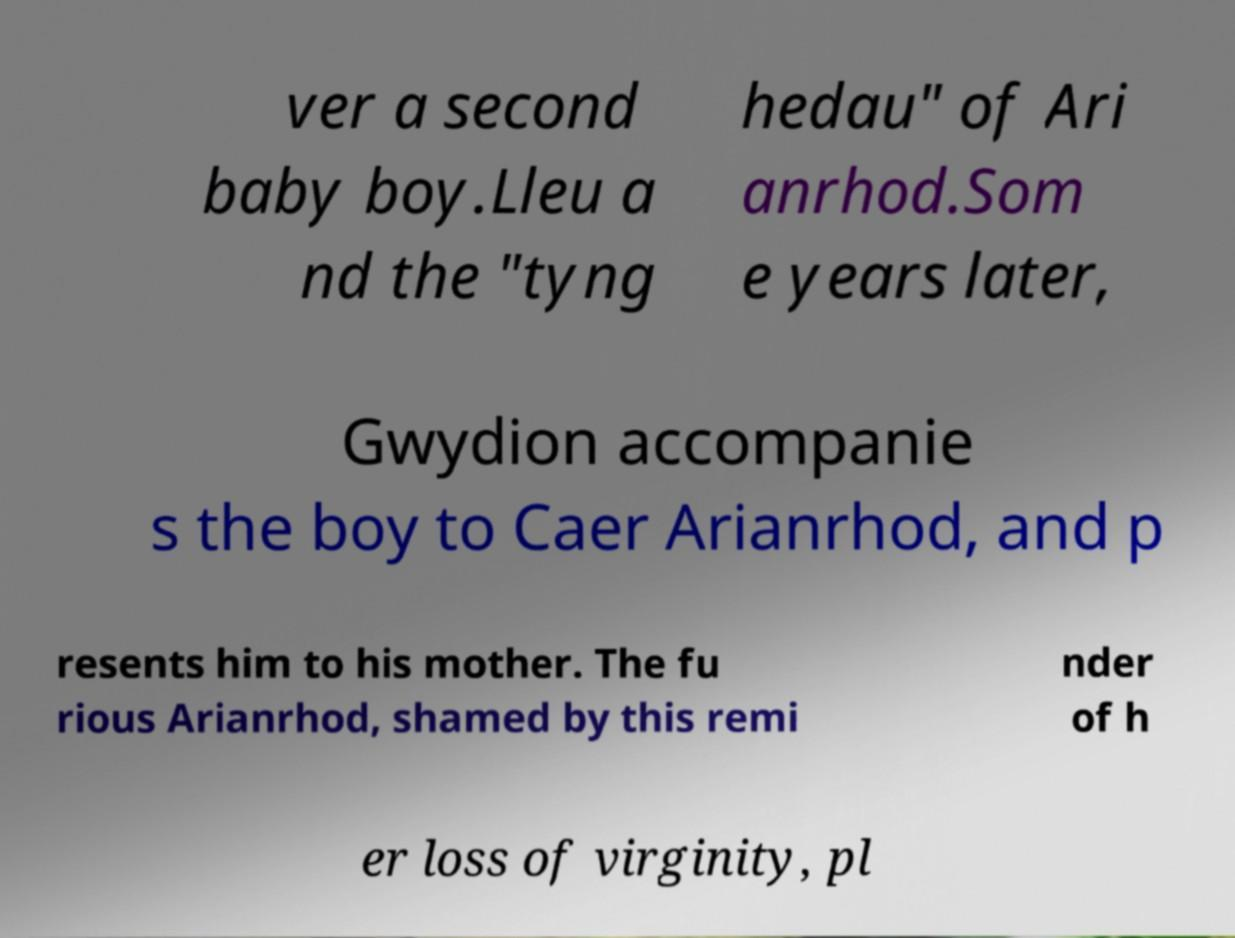I need the written content from this picture converted into text. Can you do that? ver a second baby boy.Lleu a nd the "tyng hedau" of Ari anrhod.Som e years later, Gwydion accompanie s the boy to Caer Arianrhod, and p resents him to his mother. The fu rious Arianrhod, shamed by this remi nder of h er loss of virginity, pl 